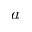Convert formula to latex. <formula><loc_0><loc_0><loc_500><loc_500>a</formula> 